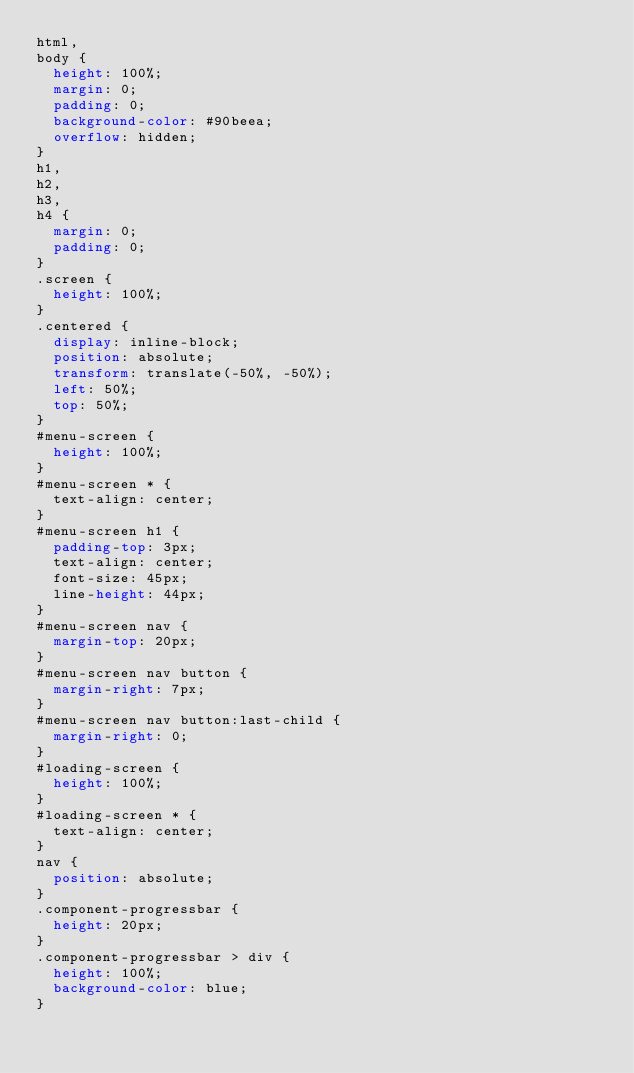Convert code to text. <code><loc_0><loc_0><loc_500><loc_500><_CSS_>html,
body {
  height: 100%;
  margin: 0;
  padding: 0;
  background-color: #90beea;
  overflow: hidden;
}
h1,
h2,
h3,
h4 {
  margin: 0;
  padding: 0;
}
.screen {
  height: 100%;
}
.centered {
  display: inline-block;
  position: absolute;
  transform: translate(-50%, -50%);
  left: 50%;
  top: 50%;
}
#menu-screen {
  height: 100%;
}
#menu-screen * {
  text-align: center;
}
#menu-screen h1 {
  padding-top: 3px;
  text-align: center;
  font-size: 45px;
  line-height: 44px;
}
#menu-screen nav {
  margin-top: 20px;
}
#menu-screen nav button {
  margin-right: 7px;
}
#menu-screen nav button:last-child {
  margin-right: 0;
}
#loading-screen {
  height: 100%;
}
#loading-screen * {
  text-align: center;
}
nav {
  position: absolute;
}
.component-progressbar {
  height: 20px;
}
.component-progressbar > div {
  height: 100%;
  background-color: blue;
}
</code> 